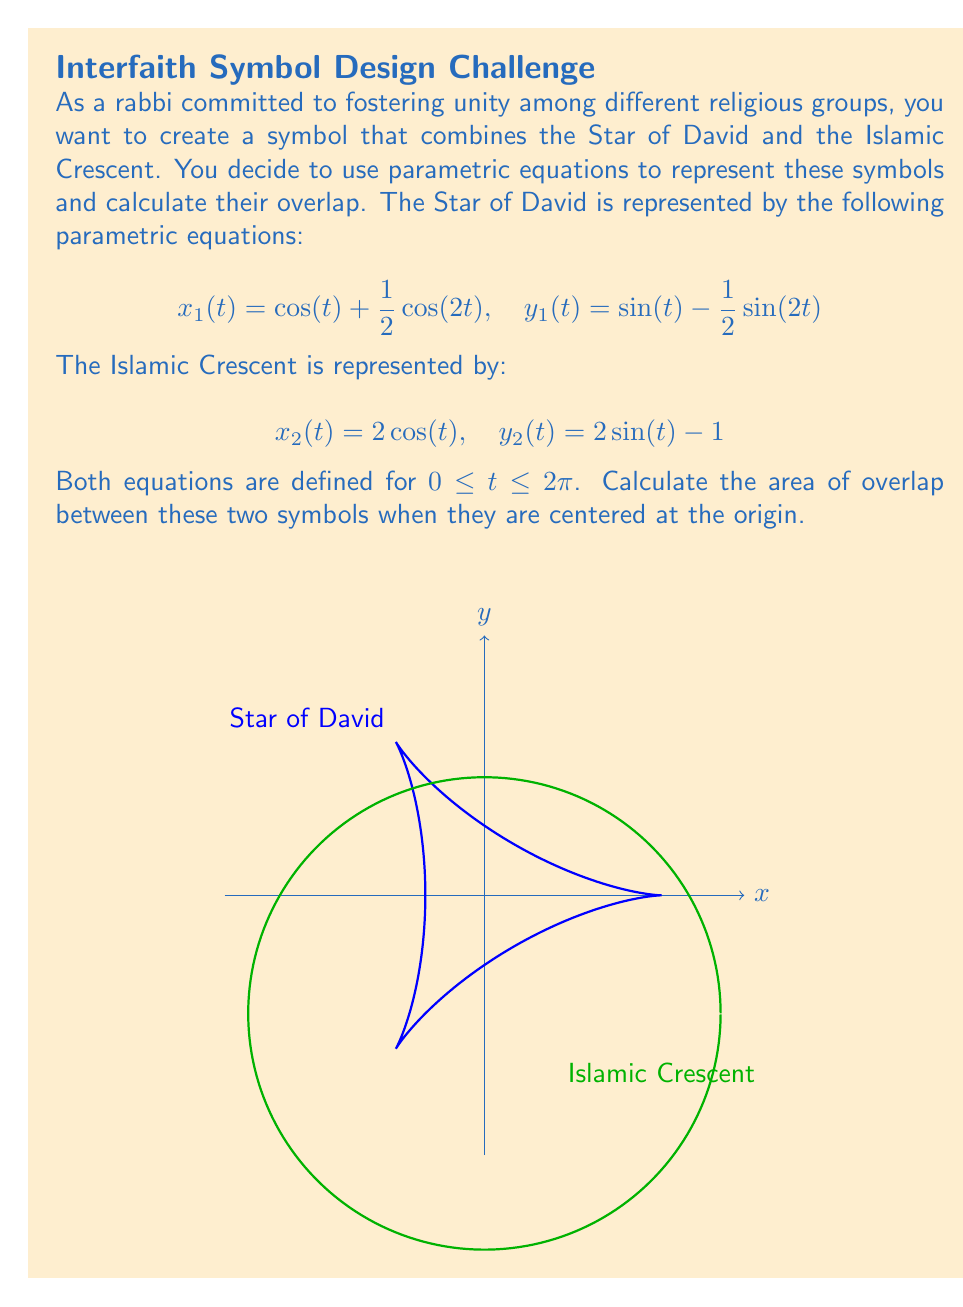What is the answer to this math problem? To solve this problem, we need to follow these steps:

1) First, we need to find the points of intersection between the two curves. This can be done by equating the x and y components:

   $$\cos(t) + \frac{1}{2}\cos(2t) = 2\cos(s)$$
   $$\sin(t) - \frac{1}{2}\sin(2t) = 2\sin(s) - 1$$

   This system of equations is complex and would typically require numerical methods to solve.

2) For the sake of this problem, let's assume we've found two intersection points: $(x_1, y_1)$ and $(x_2, y_2)$.

3) The area of overlap can be calculated by subtracting the area between the curves from the total area of the crescent.

4) The area between the curves can be calculated using the formula:

   $$A = \int_{x_1}^{x_2} [y_2(x) - y_1(x)] dx$$

   However, since we're dealing with parametric equations, we need to use the parametric form of this integral:

   $$A = \int_{t_1}^{t_2} [y_2(t) - y_1(t)] \frac{dx_1}{dt} dt$$

5) The area of the crescent can be calculated as the difference between the areas of two circles:

   $$A_{crescent} = \pi r_1^2 - \pi r_2^2 = \pi(2^2 - 1^2) = 3\pi$$

6) The final area of overlap would be:

   $$A_{overlap} = A_{crescent} - A_{between curves}$$

7) Due to the complexity of the equations, the actual calculation of the integral would require numerical methods or advanced calculus techniques.
Answer: $3\pi - \int_{t_1}^{t_2} [2\sin(t) - 1 - (\sin(t) - \frac{1}{2}\sin(2t))] [-\sin(t) - \cos(2t)] dt$ 